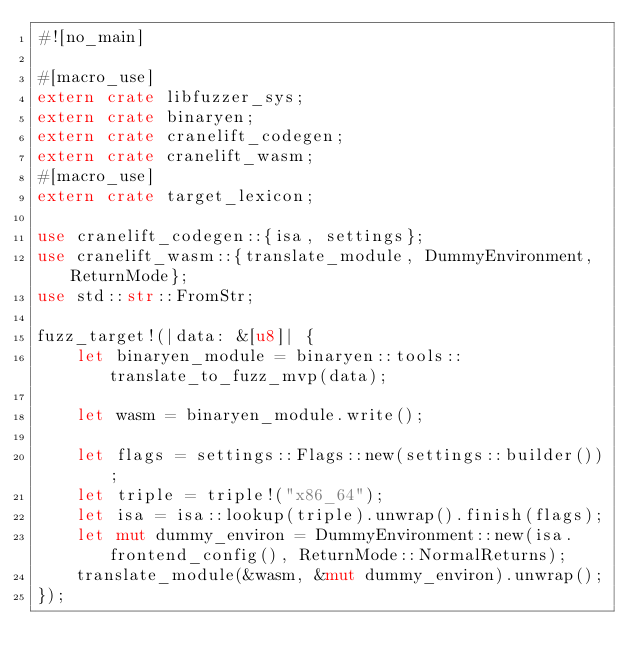Convert code to text. <code><loc_0><loc_0><loc_500><loc_500><_Rust_>#![no_main]

#[macro_use]
extern crate libfuzzer_sys;
extern crate binaryen;
extern crate cranelift_codegen;
extern crate cranelift_wasm;
#[macro_use]
extern crate target_lexicon;

use cranelift_codegen::{isa, settings};
use cranelift_wasm::{translate_module, DummyEnvironment, ReturnMode};
use std::str::FromStr;

fuzz_target!(|data: &[u8]| {
    let binaryen_module = binaryen::tools::translate_to_fuzz_mvp(data);

    let wasm = binaryen_module.write();

    let flags = settings::Flags::new(settings::builder());
    let triple = triple!("x86_64");
    let isa = isa::lookup(triple).unwrap().finish(flags);
    let mut dummy_environ = DummyEnvironment::new(isa.frontend_config(), ReturnMode::NormalReturns);
    translate_module(&wasm, &mut dummy_environ).unwrap();
});
</code> 